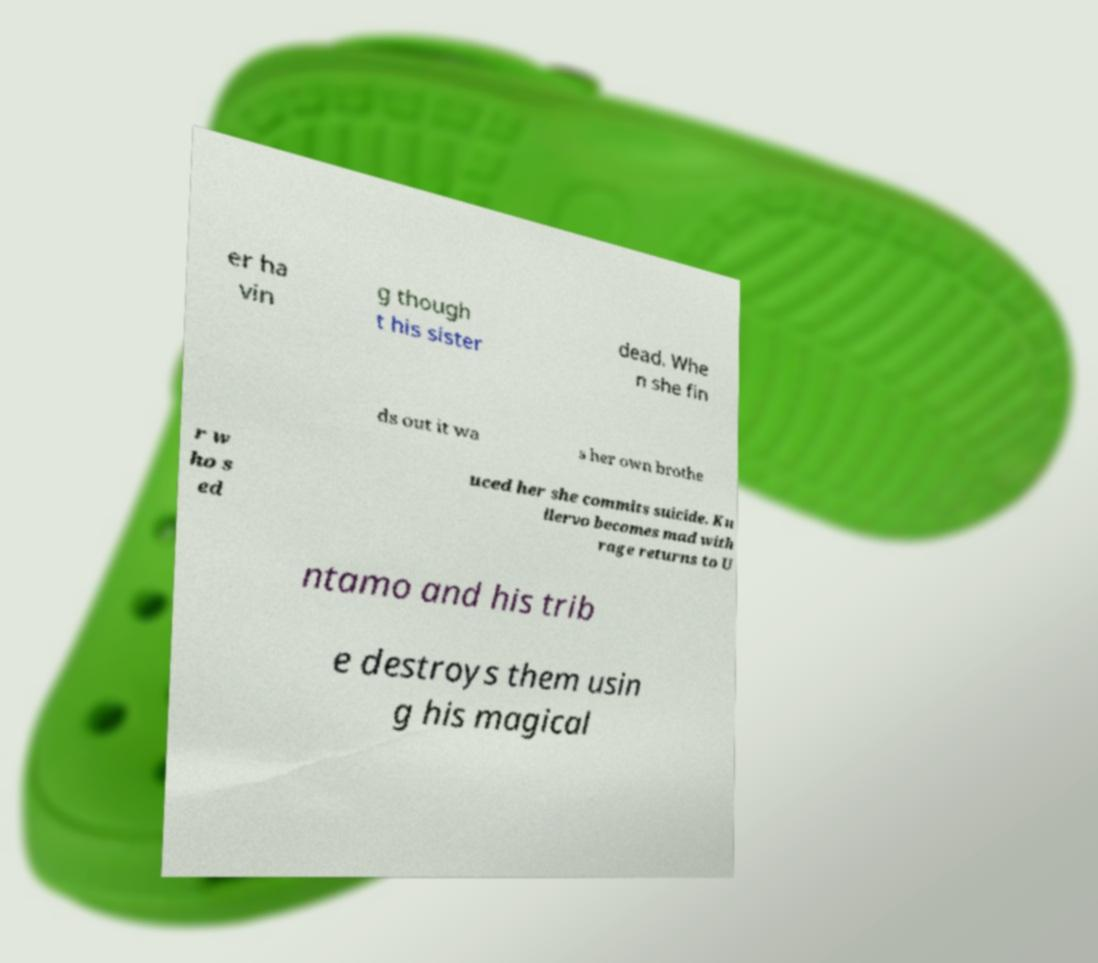There's text embedded in this image that I need extracted. Can you transcribe it verbatim? er ha vin g though t his sister dead. Whe n she fin ds out it wa s her own brothe r w ho s ed uced her she commits suicide. Ku llervo becomes mad with rage returns to U ntamo and his trib e destroys them usin g his magical 